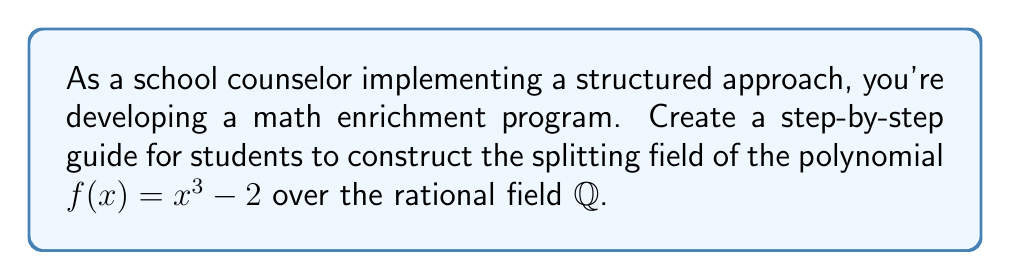Teach me how to tackle this problem. Let's approach this systematically:

1) First, we need to find the roots of $f(x) = x^3 - 2$. One real root is obvious: $\sqrt[3]{2}$.

2) To find the other roots, we can use the complex cube roots of unity. Let $\omega = e^{2\pi i/3} = -\frac{1}{2} + i\frac{\sqrt{3}}{2}$.

3) The three cube roots of 2 are:
   $\sqrt[3]{2}$, $\omega\sqrt[3]{2}$, and $\omega^2\sqrt[3]{2}$

4) Now, we need to adjoin these roots to $\mathbb{Q}$ to create the splitting field. Let's do this step-by-step:

   a) First, adjoin $\sqrt[3]{2}$ to $\mathbb{Q}$:
      $\mathbb{Q}(\sqrt[3]{2})$

   b) Next, we need to adjoin $\omega$. This is equivalent to adjoining $\sqrt{-3}$, as $\omega = -\frac{1}{2} + i\frac{\sqrt{3}}{2} = -\frac{1}{2} + \frac{\sqrt{-3}}{2}$

5) Therefore, the splitting field is:
   $\mathbb{Q}(\sqrt[3]{2}, \sqrt{-3})$

This field contains all the roots of $f(x)$, as $\omega\sqrt[3]{2}$ and $\omega^2\sqrt[3]{2}$ can be expressed using $\sqrt[3]{2}$ and $\sqrt{-3}$.
Answer: $\mathbb{Q}(\sqrt[3]{2}, \sqrt{-3})$ 